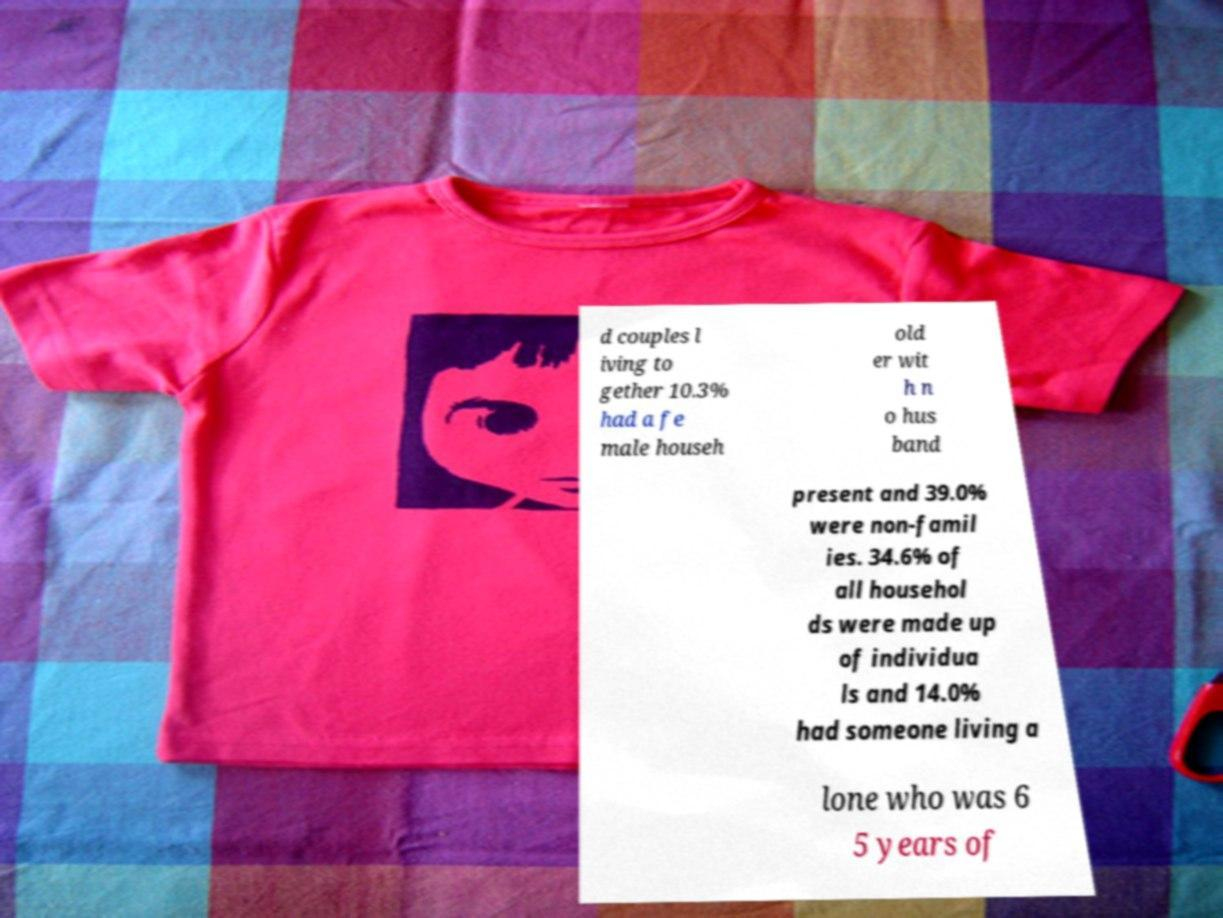Please read and relay the text visible in this image. What does it say? d couples l iving to gether 10.3% had a fe male househ old er wit h n o hus band present and 39.0% were non-famil ies. 34.6% of all househol ds were made up of individua ls and 14.0% had someone living a lone who was 6 5 years of 